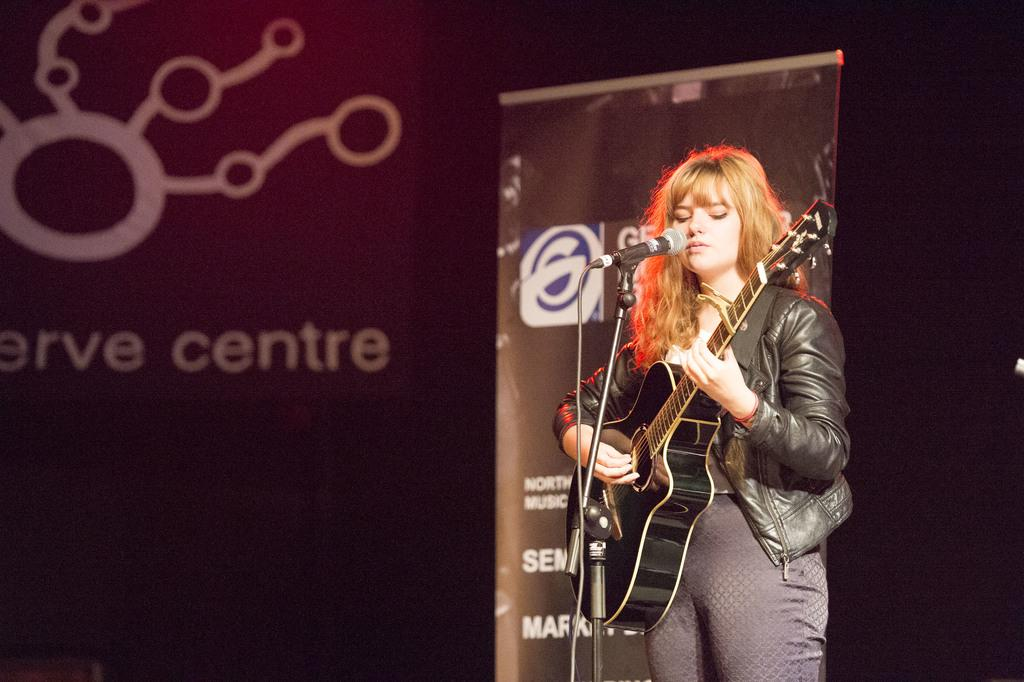What is the main subject of the image? The main subject of the image is a woman. What is the woman doing in the image? The woman is standing, playing a guitar, singing a song, and using a microphone. What can be seen in the background of the image? There is a banner and a hoarding in the background of the image. How many mice can be seen running around the woman's feet in the image? There are no mice present in the image. What type of iron is the woman using to play the guitar in the image? The woman is not using any iron to play the guitar; she is using a guitar. 